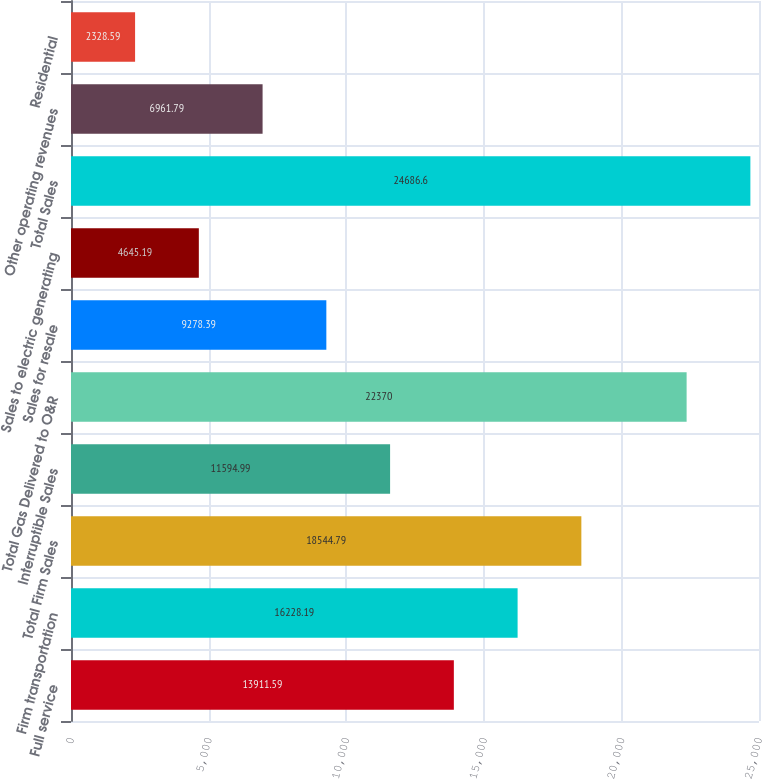Convert chart to OTSL. <chart><loc_0><loc_0><loc_500><loc_500><bar_chart><fcel>Full service<fcel>Firm transportation<fcel>Total Firm Sales<fcel>Interruptible Sales<fcel>Total Gas Delivered to O&R<fcel>Sales for resale<fcel>Sales to electric generating<fcel>Total Sales<fcel>Other operating revenues<fcel>Residential<nl><fcel>13911.6<fcel>16228.2<fcel>18544.8<fcel>11595<fcel>22370<fcel>9278.39<fcel>4645.19<fcel>24686.6<fcel>6961.79<fcel>2328.59<nl></chart> 